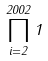<formula> <loc_0><loc_0><loc_500><loc_500>\prod _ { i = 2 } ^ { 2 0 0 2 } 1</formula> 